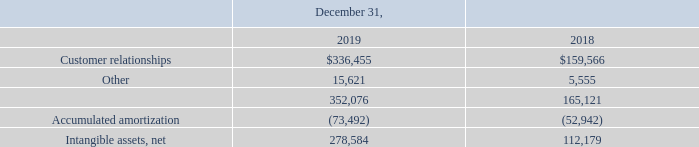(6) Intangible Assets
Intangible assets consist of the following (in thousands):
During 2019, we periodically assessed whether any indicators of impairment existed related to our intangible assets. As of each interim period end during the year, we concluded that a triggering event had not occurred that would more likely than not reduce the fair value of our intangible assets below their carrying values.
Amortization expense recognized in 2019, 2018 and 2017 was $23,671,000, $15,737,000 and $16,812,000, respectively.
How much was the Amortization expense in 2019? $23,671,000. How much was the Amortization expense in 2018? $15,737,000. How much was the Amortization expense in 2017? $16,812,000. What is the change in Accumulated amortization between 2018 and 2019?
Answer scale should be: thousand. 73,492-52,942
Answer: 20550. What is the change in Intangible assets, net between 2018 and 2019?
Answer scale should be: thousand. 278,584-112,179
Answer: 166405. What is the average Accumulated amortization for 2018 and 2019?
Answer scale should be: thousand. (73,492+52,942) / 2
Answer: 63217. 